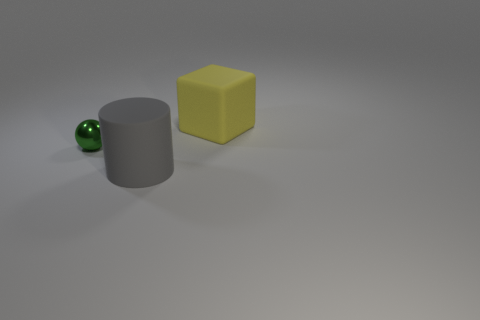Add 1 yellow blocks. How many objects exist? 4 Subtract all spheres. How many objects are left? 2 Subtract 0 brown cylinders. How many objects are left? 3 Subtract all big yellow objects. Subtract all big matte cylinders. How many objects are left? 1 Add 3 large gray matte cylinders. How many large gray matte cylinders are left? 4 Add 1 large red things. How many large red things exist? 1 